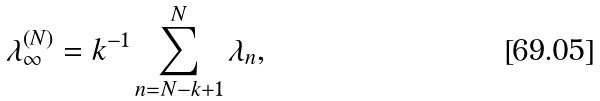<formula> <loc_0><loc_0><loc_500><loc_500>\lambda _ { \infty } ^ { ( N ) } = k ^ { - 1 } \sum _ { n = N - k + 1 } ^ { N } \lambda _ { n } ,</formula> 